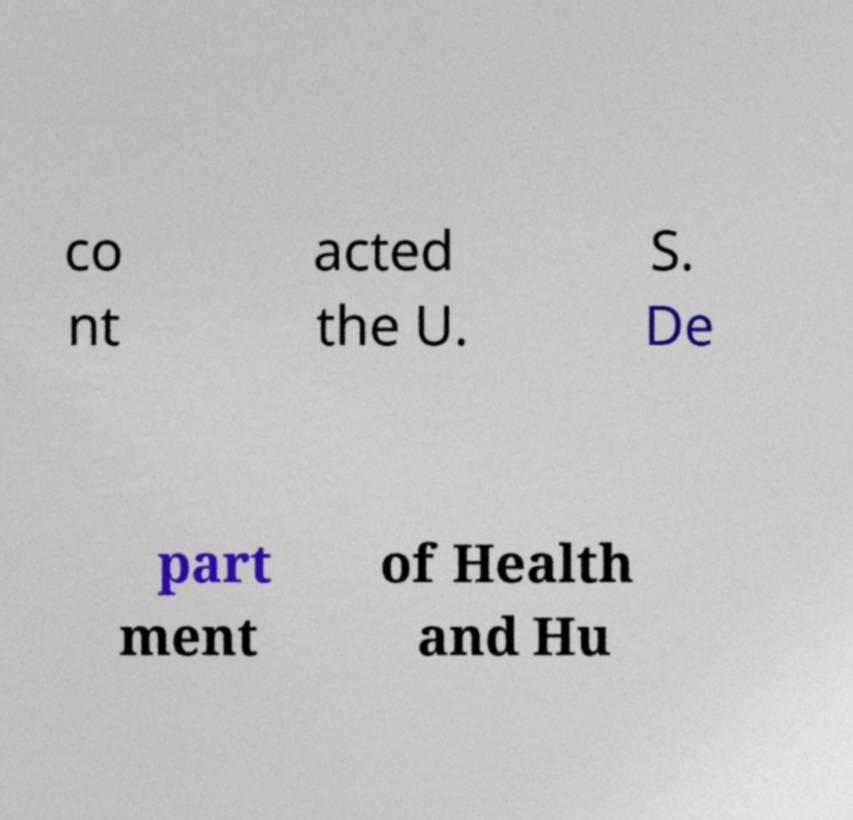There's text embedded in this image that I need extracted. Can you transcribe it verbatim? co nt acted the U. S. De part ment of Health and Hu 